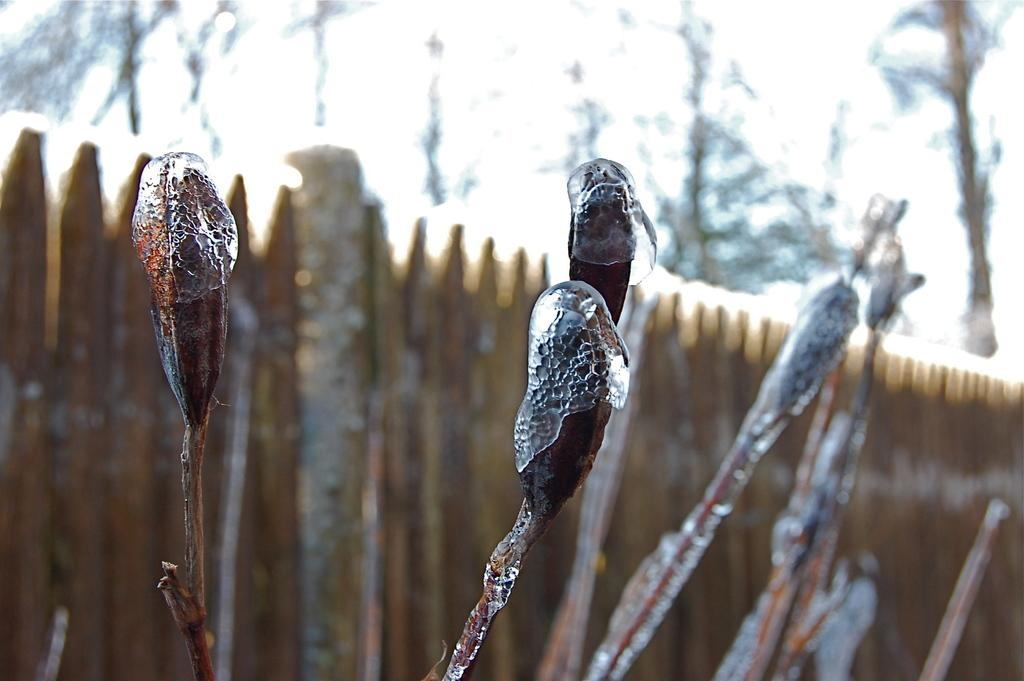What is present in the image? There is a plant in the image. What is unique about the plant? The plant is covered with ice flakes. What can be seen in the background of the image? There is a wooden fence in the background of the image. What type of haircut does the plant have in the image? The plant does not have a haircut, as it is a plant and not a person. 